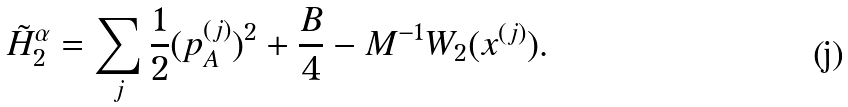<formula> <loc_0><loc_0><loc_500><loc_500>\tilde { H } ^ { \alpha } _ { 2 } & = \sum _ { j } \frac { 1 } { 2 } ( { p } _ { A } ^ { ( j ) } ) ^ { 2 } + \frac { B } { 4 } - M ^ { - 1 } W _ { 2 } ( x ^ { ( j ) } ) .</formula> 